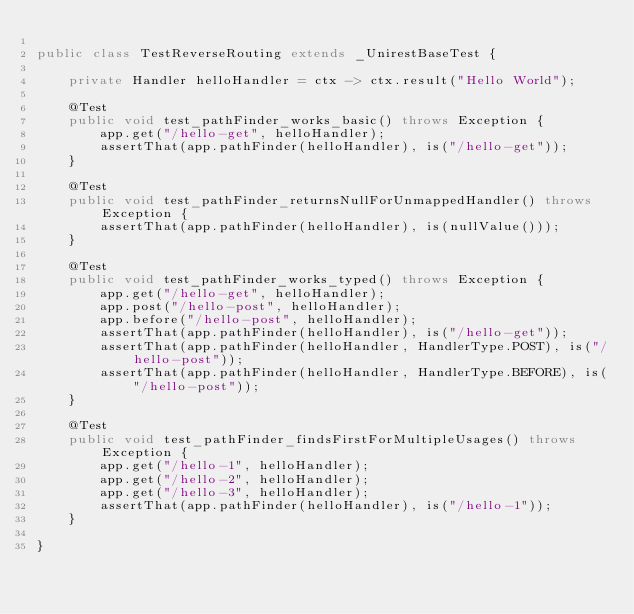Convert code to text. <code><loc_0><loc_0><loc_500><loc_500><_Java_>
public class TestReverseRouting extends _UnirestBaseTest {

    private Handler helloHandler = ctx -> ctx.result("Hello World");

    @Test
    public void test_pathFinder_works_basic() throws Exception {
        app.get("/hello-get", helloHandler);
        assertThat(app.pathFinder(helloHandler), is("/hello-get"));
    }

    @Test
    public void test_pathFinder_returnsNullForUnmappedHandler() throws Exception {
        assertThat(app.pathFinder(helloHandler), is(nullValue()));
    }

    @Test
    public void test_pathFinder_works_typed() throws Exception {
        app.get("/hello-get", helloHandler);
        app.post("/hello-post", helloHandler);
        app.before("/hello-post", helloHandler);
        assertThat(app.pathFinder(helloHandler), is("/hello-get"));
        assertThat(app.pathFinder(helloHandler, HandlerType.POST), is("/hello-post"));
        assertThat(app.pathFinder(helloHandler, HandlerType.BEFORE), is("/hello-post"));
    }

    @Test
    public void test_pathFinder_findsFirstForMultipleUsages() throws Exception {
        app.get("/hello-1", helloHandler);
        app.get("/hello-2", helloHandler);
        app.get("/hello-3", helloHandler);
        assertThat(app.pathFinder(helloHandler), is("/hello-1"));
    }

}
</code> 